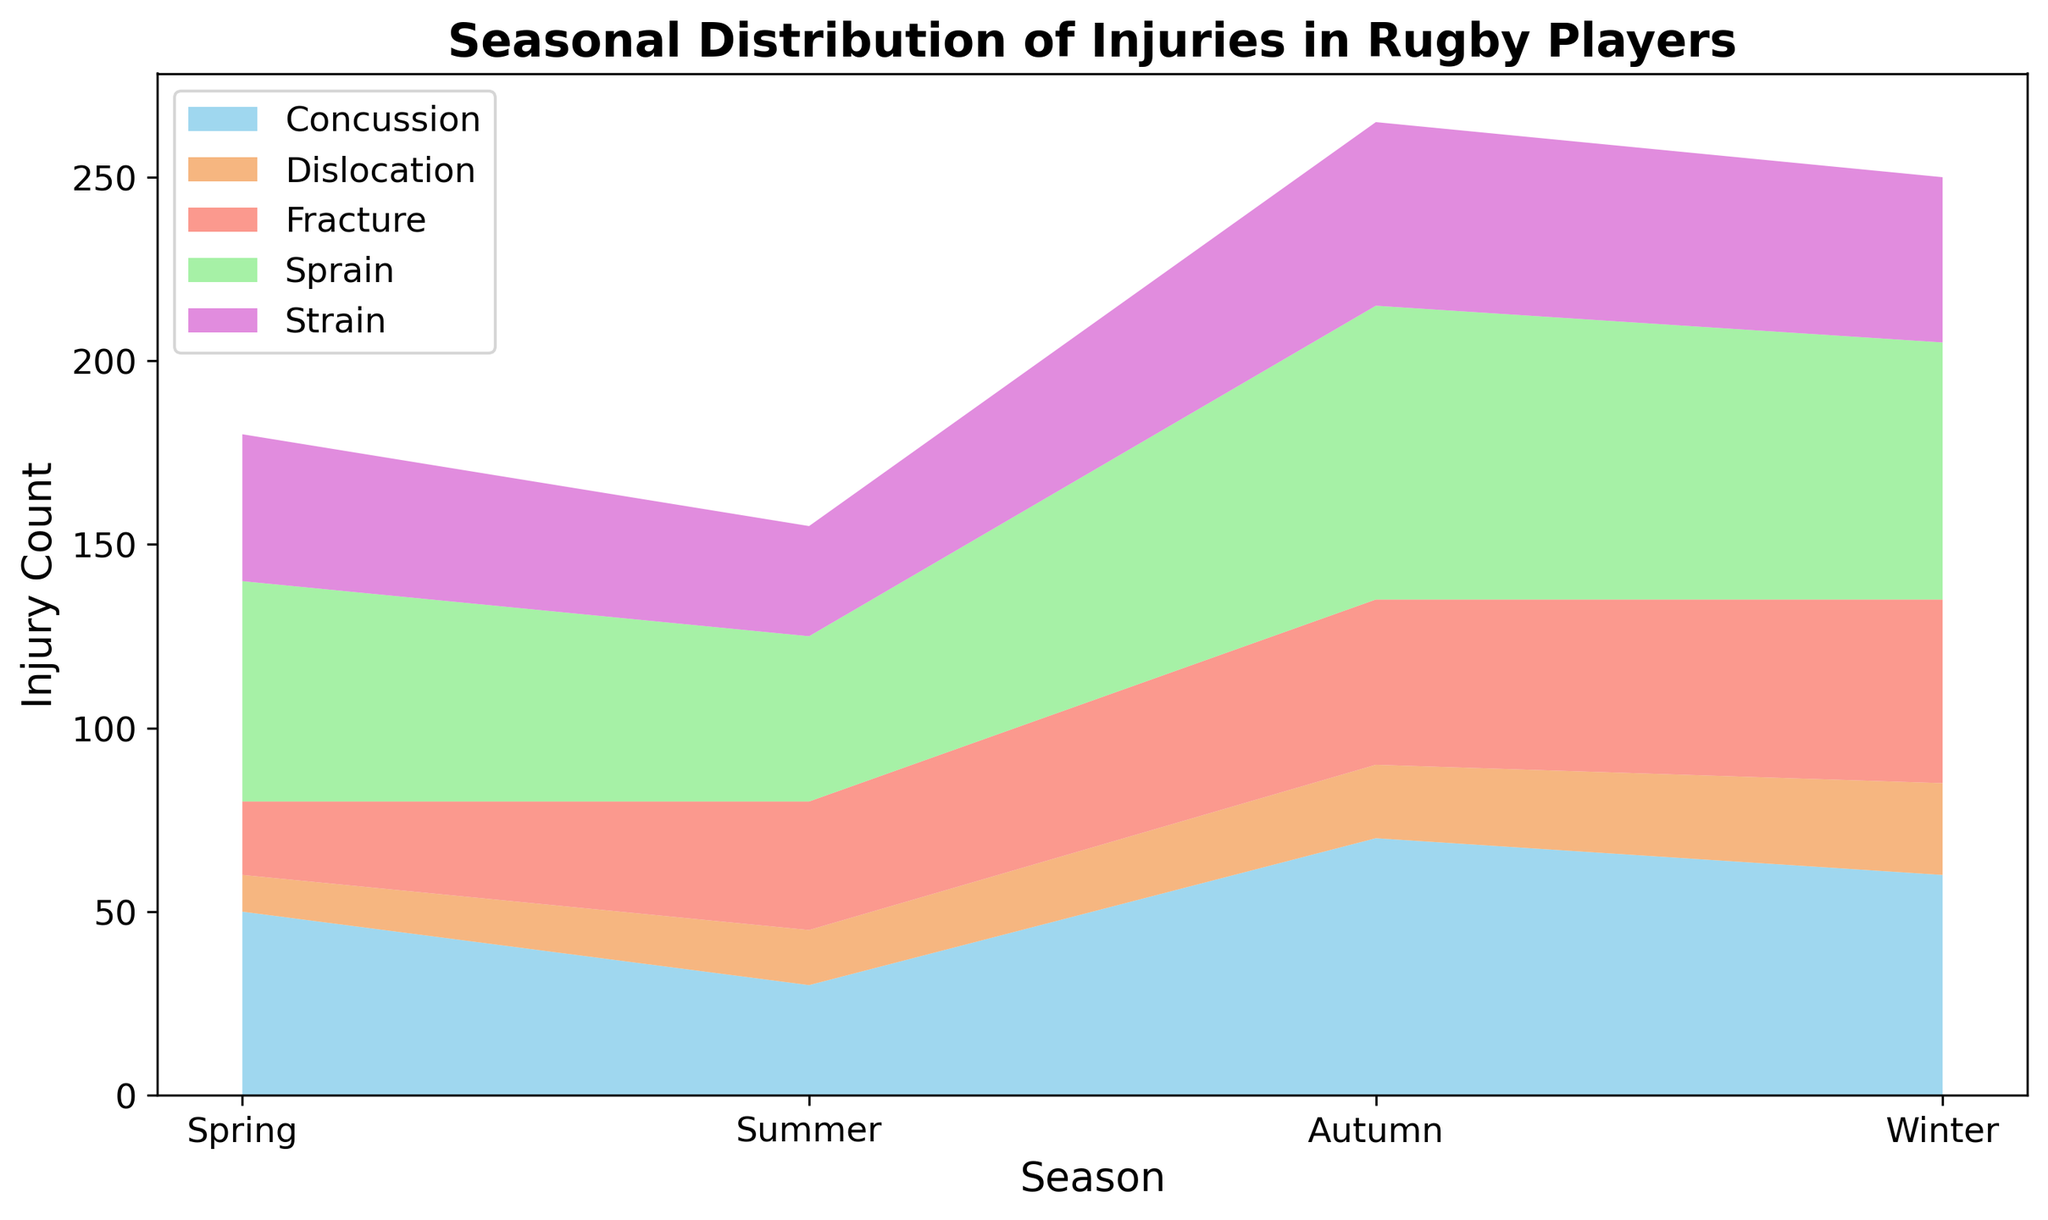What season has the highest overall injury count? To find the season with the highest overall injury count, we sum the injury counts across all injury types for each season and compare the totals. Spring: 50+20+60+10+40=180, Summer: 30+35+45+15+30=155, Autumn: 70+45+80+20+50=265, Winter: 60+50+70+25+45=250. The highest total is in Autumn with 265.
Answer: Autumn Which injury type has the lowest count in Summer? Look at the segment with the least height in the Summer area of the chart. Dislocation is the lowest with an injury count of 15.
Answer: Dislocation How much more common are sprains in Autumn compared to Summer? Identify the heights of the segments representing sprains in Autumn (80) and Summer (45). Subtract the Summer count from the Autumn count: 80 - 45 = 35.
Answer: 35 Which injury type has the highest count in Spring? Locate the segment with the greatest height in the Spring area of the chart. The highest segment is for Sprain with an injury count of 60.
Answer: Sprain What is the total number of fracture injuries across all seasons? Sum the fracture counts from each season: 20 (Spring) + 35 (Summer) + 45 (Autumn) + 50 (Winter) = 150.
Answer: 150 Compare the total injuries between Winter and Summer. Which is greater? Sum the injury counts for each season and compare. Winter: 60+50+70+25+45=250, Summer: 30+35+45+15+30=155. Winter has more total injuries.
Answer: Winter Which season has the least number of concussions? Check the segments representing concussions across all seasons. The smallest height is in Summer with a count of 30.
Answer: Summer Are strains more common in Spring or Winter? Compare the heights of the strain segments in Spring (40) and Winter (45). Winter has slightly more.
Answer: Winter What is the average injury count for concussions across all seasons? Add the counts for concussions across all seasons and divide by the number of seasons: (50+30+70+60)/4 = 210/4 = 52.5.
Answer: 52.5 How many more injuries occur in Autumn compared to Spring for all injury types combined? Calculate the total injuries for Autumn (265) and Spring (180) and subtract: 265 - 180 = 85.
Answer: 85 